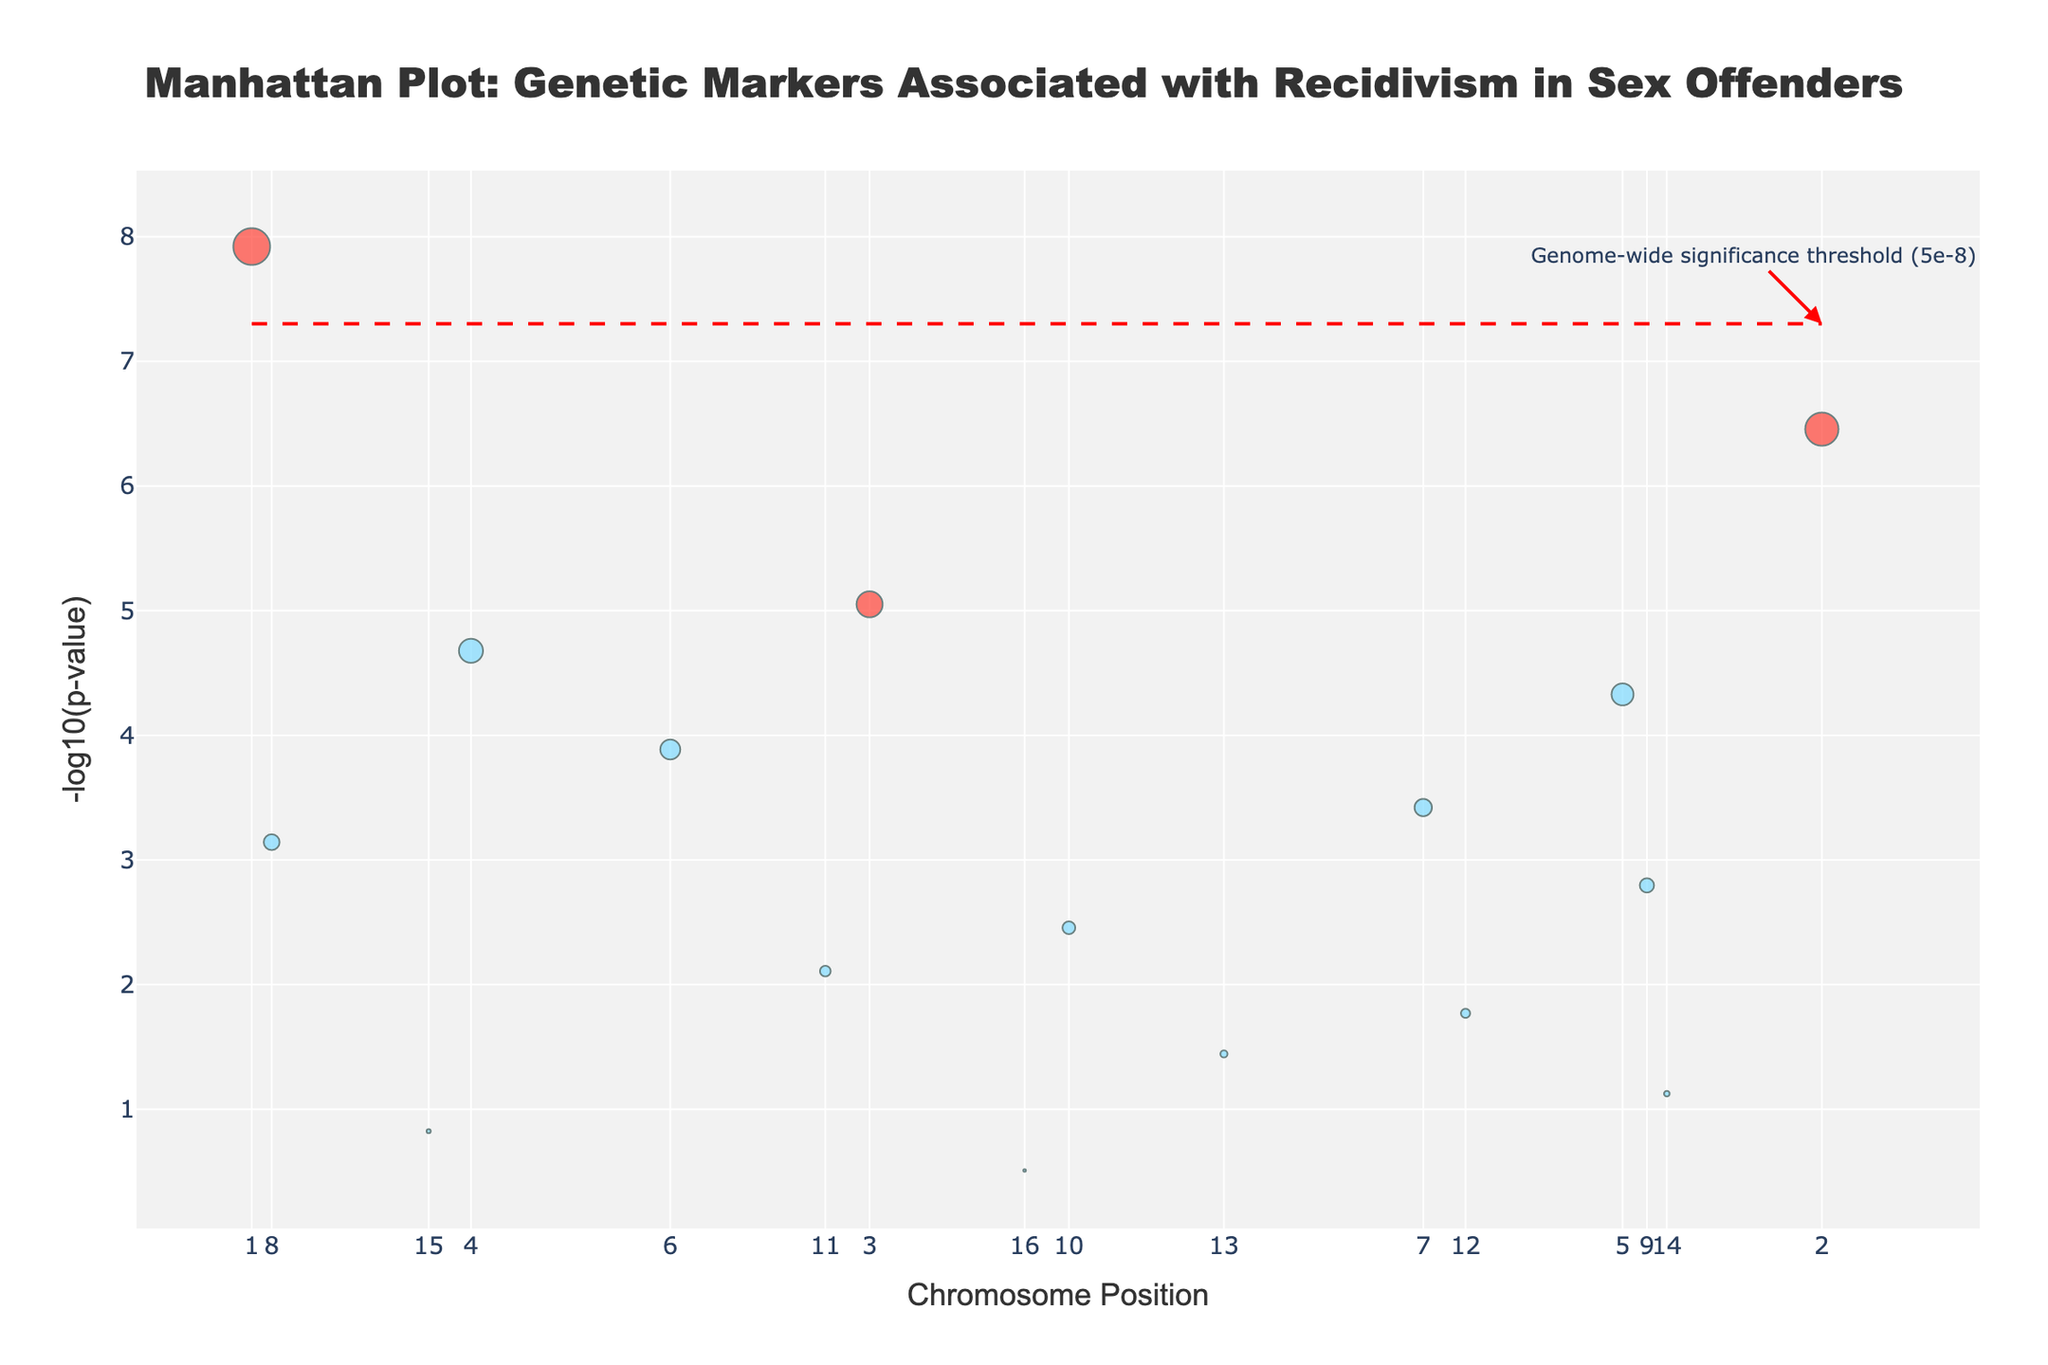What's the title of the plot? The title is usually shown at the top of the plot, and it helps describe what the plot is about. In this plot, the title is centered at the top of the image.
Answer: Manhattan Plot: Genetic Markers Associated with Recidivism in Sex Offenders What does the x-axis represent? The x-axis usually indicates the position of data points. In this case, the tick labels correspond to chromosome numbers, and the title indicates it represents chromosome positions.
Answer: Chromosome Position What does the y-axis represent? The y-axis labels and title indicate the variable being measured. It is typically denoted in a format recognizable from statistical plots. In this case, it represents the negative logarithm to the base ten of the P-values.
Answer: -log10(p-value) Which gene has the highest association strength? The gene with the highest association strength will have the largest marker size on the plot. The data indicates that MAOA has the highest association strength (7.2) among the genes listed.
Answer: MAOA How many genetic markers surpass the genome-wide significance threshold? By identifying markers above the threshold line on the y-axis, we note that only one marker is significantly above this line.
Answer: 1 Compare the Association Strength of genes MAOA and SLC6A4. Which one is stronger? The association strengths are provided in the data: MAOA has a value of 7.2, while SLC6A4 has a value of 6.5. Therefore, MAOA is stronger.
Answer: MAOA Which chromosome has the genetic marker with the lowest p-value? The lowest p-value on the y-axis corresponds to the highest -log10(p-value) on this Manhattan plot. This is associated with chromosome 1, as MAOA has the lowest p-value of 1.2e-8.
Answer: Chromosome 1 What is the significance threshold level annotated on the plot? The horizontal line and accompanying annotation on the plot indicate a specific p-value threshold. This plot includes a line annotated as the genome-wide significance threshold at 5e-8.
Answer: 5e-8 Which color represents genetic markers with higher association strength? The color associations for different levels are usually differentiated in the legend or described in the plot details. Here, markers with association strength greater than 5 are colored red.
Answer: Red What gene is located closest to the halfway point on the x-axis? The positions on the x-axis are ordered by chromosome position, so finding the position near the midpoint can be done by checking the chromosome number and position values. DRD4 on chromosome 4 has the closest mid-position.
Answer: DRD4 